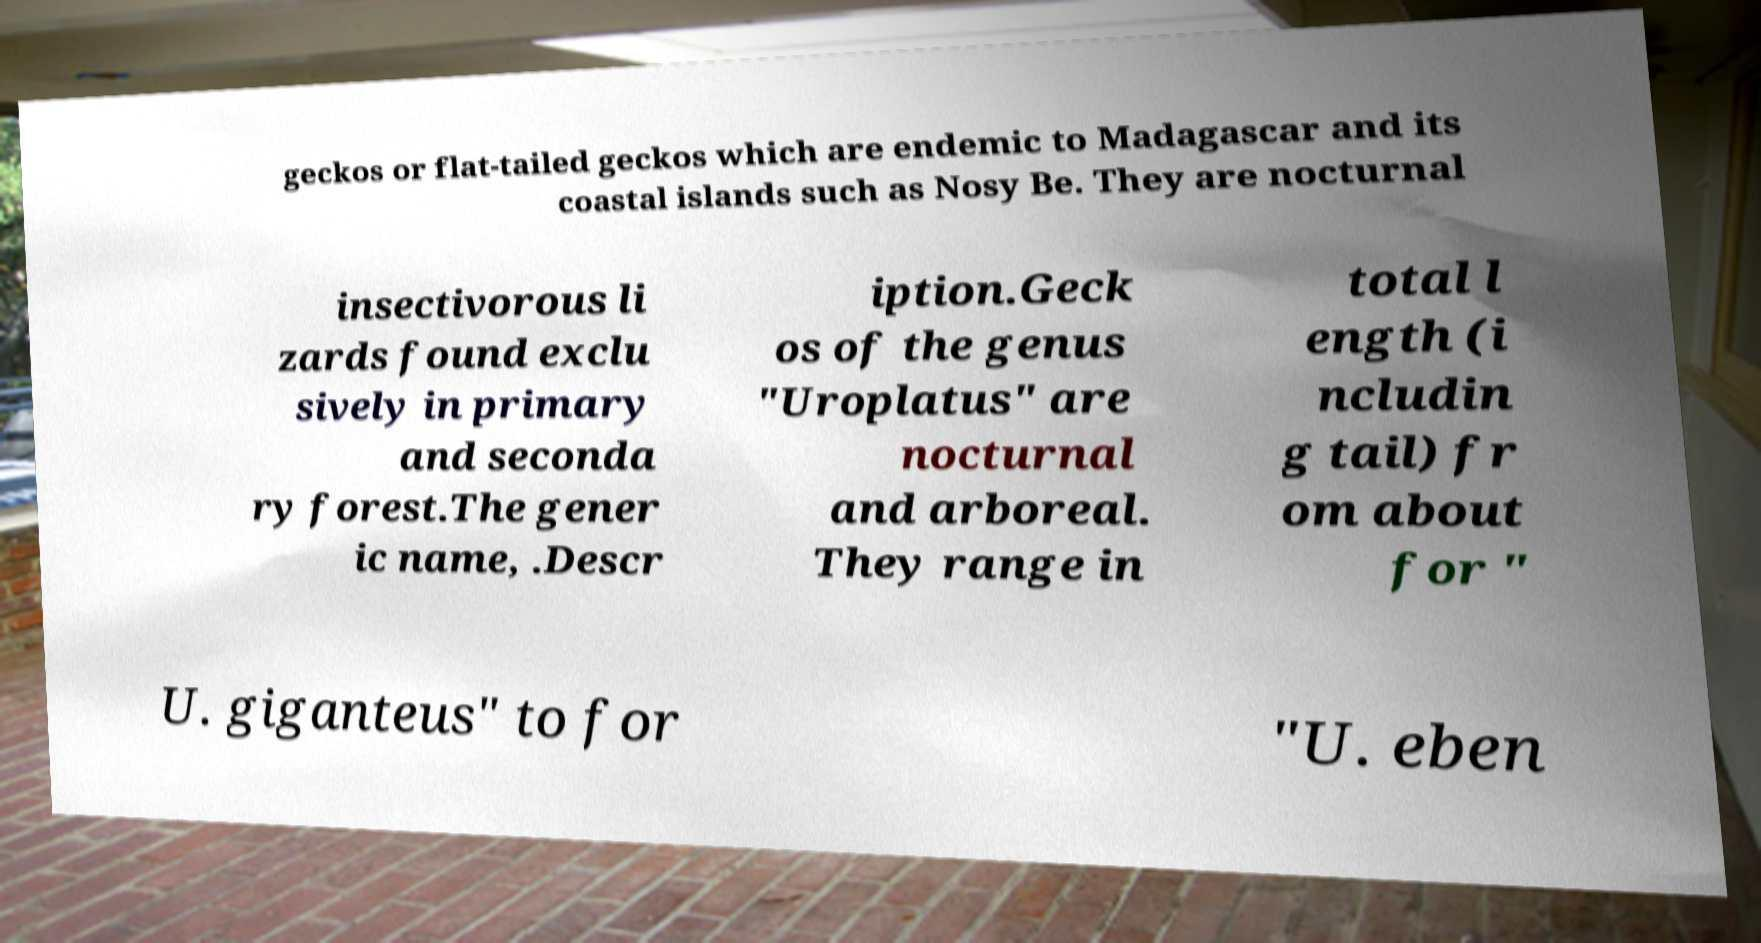Could you assist in decoding the text presented in this image and type it out clearly? geckos or flat-tailed geckos which are endemic to Madagascar and its coastal islands such as Nosy Be. They are nocturnal insectivorous li zards found exclu sively in primary and seconda ry forest.The gener ic name, .Descr iption.Geck os of the genus "Uroplatus" are nocturnal and arboreal. They range in total l ength (i ncludin g tail) fr om about for " U. giganteus" to for "U. eben 